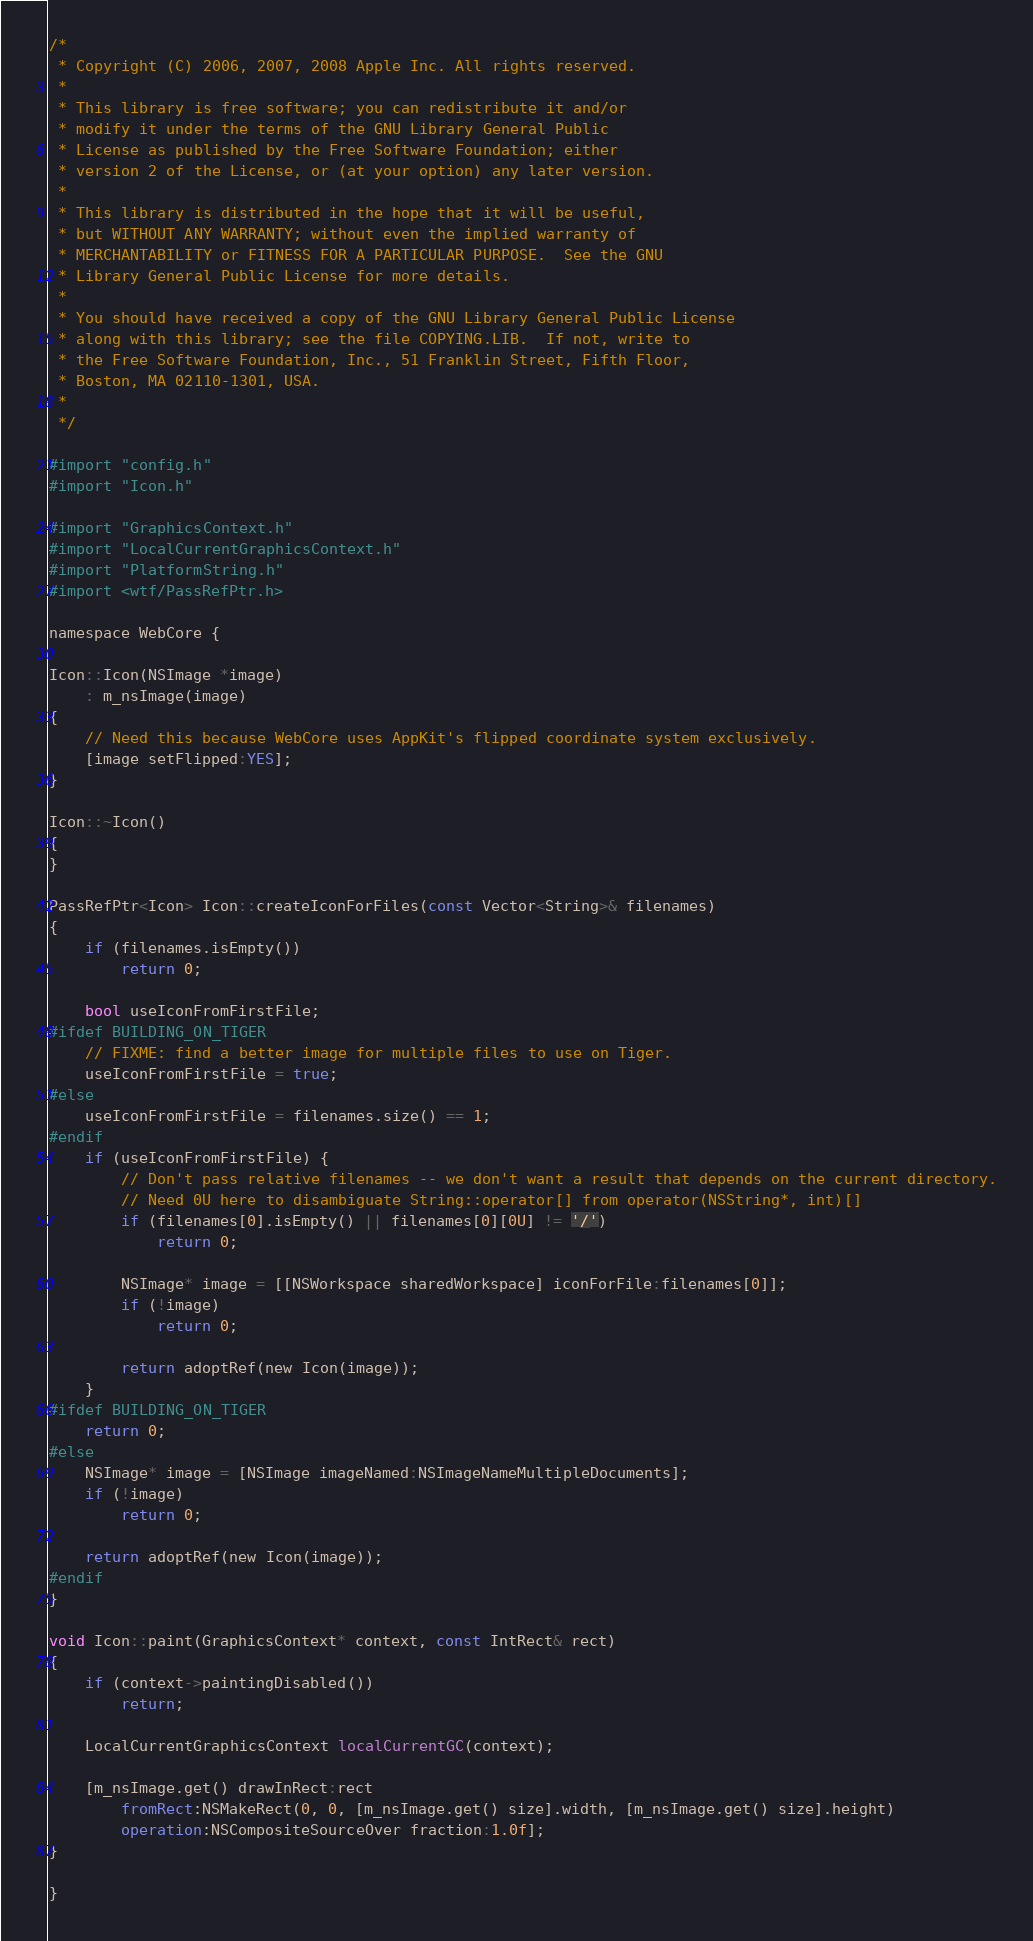Convert code to text. <code><loc_0><loc_0><loc_500><loc_500><_ObjectiveC_>/*
 * Copyright (C) 2006, 2007, 2008 Apple Inc. All rights reserved.
 *
 * This library is free software; you can redistribute it and/or
 * modify it under the terms of the GNU Library General Public
 * License as published by the Free Software Foundation; either
 * version 2 of the License, or (at your option) any later version.
 *
 * This library is distributed in the hope that it will be useful,
 * but WITHOUT ANY WARRANTY; without even the implied warranty of
 * MERCHANTABILITY or FITNESS FOR A PARTICULAR PURPOSE.  See the GNU
 * Library General Public License for more details.
 *
 * You should have received a copy of the GNU Library General Public License
 * along with this library; see the file COPYING.LIB.  If not, write to
 * the Free Software Foundation, Inc., 51 Franklin Street, Fifth Floor,
 * Boston, MA 02110-1301, USA.
 *
 */

#import "config.h"
#import "Icon.h"

#import "GraphicsContext.h"
#import "LocalCurrentGraphicsContext.h"
#import "PlatformString.h"
#import <wtf/PassRefPtr.h>

namespace WebCore {

Icon::Icon(NSImage *image)
    : m_nsImage(image)
{
    // Need this because WebCore uses AppKit's flipped coordinate system exclusively.
    [image setFlipped:YES];
}

Icon::~Icon()
{
}

PassRefPtr<Icon> Icon::createIconForFiles(const Vector<String>& filenames)
{
    if (filenames.isEmpty())
        return 0;

    bool useIconFromFirstFile;
#ifdef BUILDING_ON_TIGER
    // FIXME: find a better image for multiple files to use on Tiger.
    useIconFromFirstFile = true;
#else
    useIconFromFirstFile = filenames.size() == 1;
#endif
    if (useIconFromFirstFile) {
        // Don't pass relative filenames -- we don't want a result that depends on the current directory.
        // Need 0U here to disambiguate String::operator[] from operator(NSString*, int)[]
        if (filenames[0].isEmpty() || filenames[0][0U] != '/')
            return 0;

        NSImage* image = [[NSWorkspace sharedWorkspace] iconForFile:filenames[0]];
        if (!image)
            return 0;

        return adoptRef(new Icon(image));
    }
#ifdef BUILDING_ON_TIGER
    return 0;
#else
    NSImage* image = [NSImage imageNamed:NSImageNameMultipleDocuments];
    if (!image)
        return 0;

    return adoptRef(new Icon(image));
#endif
}

void Icon::paint(GraphicsContext* context, const IntRect& rect)
{
    if (context->paintingDisabled())
        return;

    LocalCurrentGraphicsContext localCurrentGC(context);

    [m_nsImage.get() drawInRect:rect
        fromRect:NSMakeRect(0, 0, [m_nsImage.get() size].width, [m_nsImage.get() size].height)
        operation:NSCompositeSourceOver fraction:1.0f];
}

}
</code> 